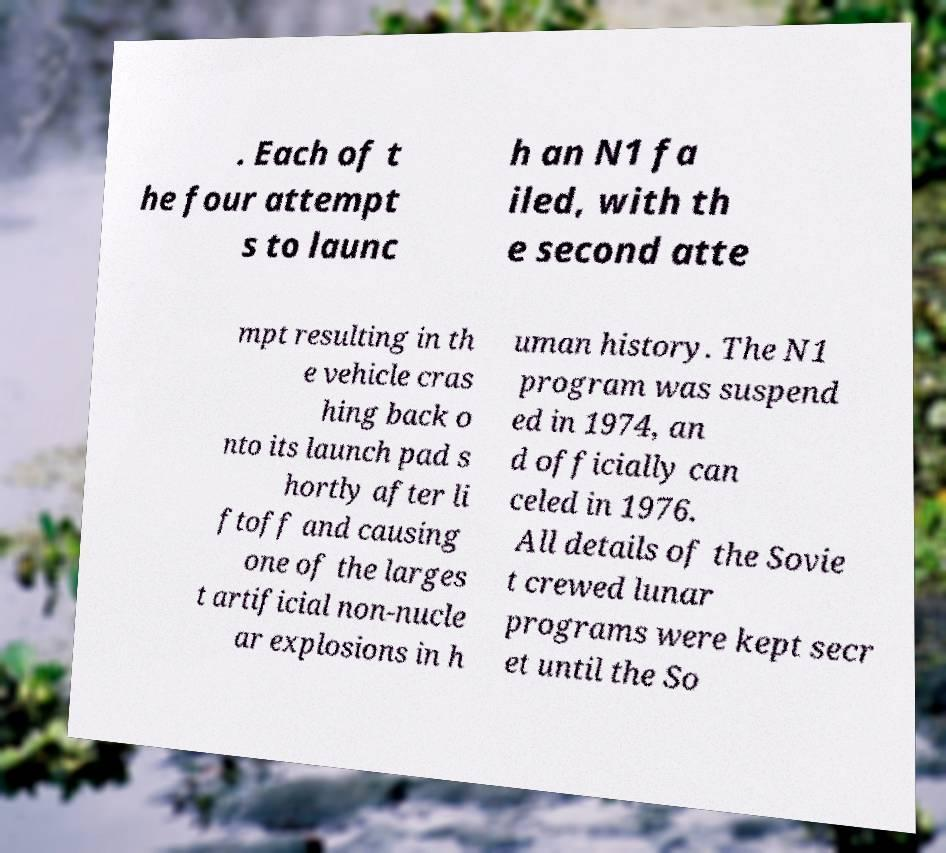Can you accurately transcribe the text from the provided image for me? . Each of t he four attempt s to launc h an N1 fa iled, with th e second atte mpt resulting in th e vehicle cras hing back o nto its launch pad s hortly after li ftoff and causing one of the larges t artificial non-nucle ar explosions in h uman history. The N1 program was suspend ed in 1974, an d officially can celed in 1976. All details of the Sovie t crewed lunar programs were kept secr et until the So 